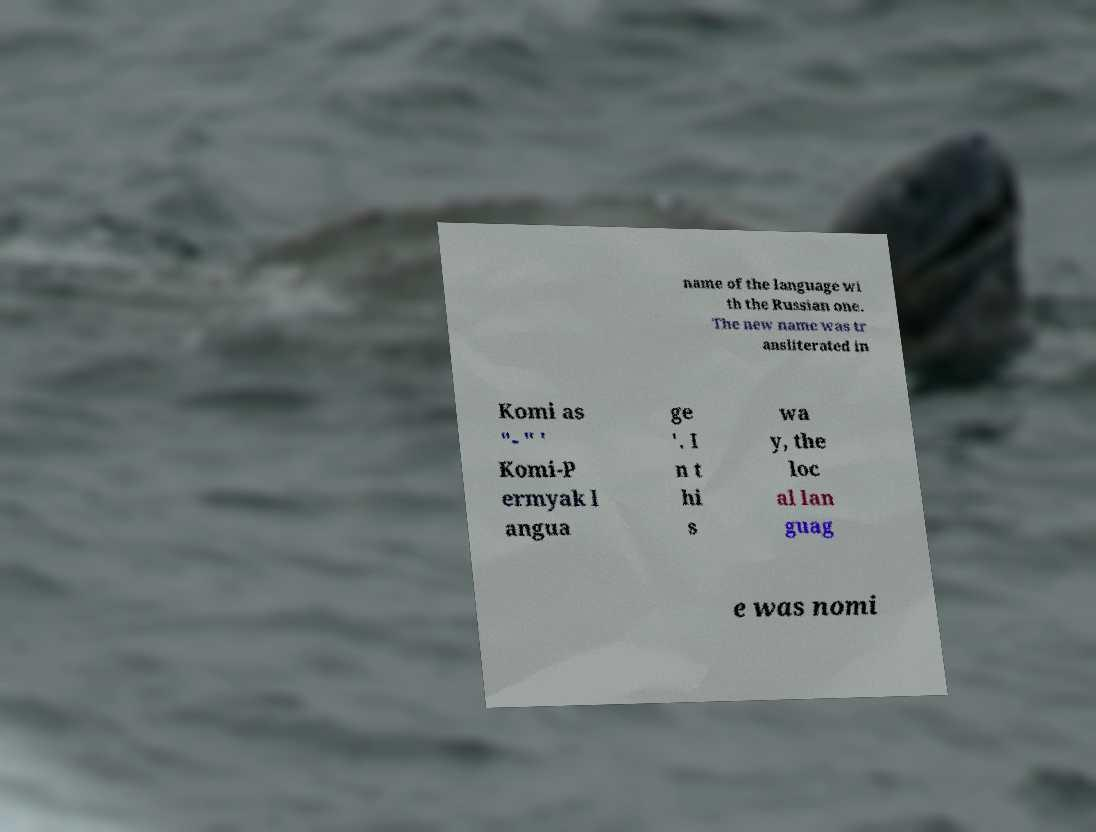I need the written content from this picture converted into text. Can you do that? name of the language wi th the Russian one. The new name was tr ansliterated in Komi as "- " ' Komi-P ermyak l angua ge '. I n t hi s wa y, the loc al lan guag e was nomi 